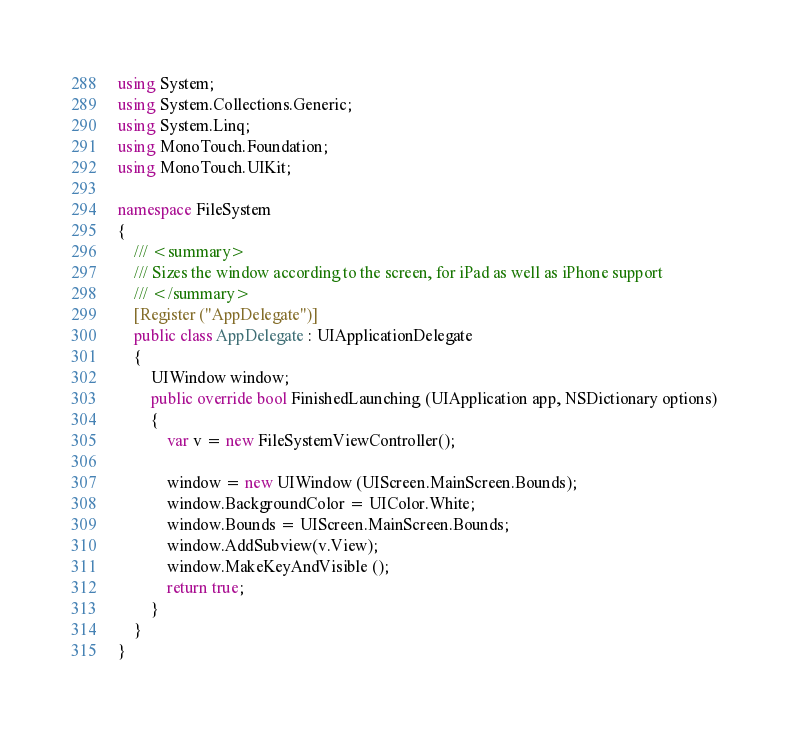<code> <loc_0><loc_0><loc_500><loc_500><_C#_>
using System;
using System.Collections.Generic;
using System.Linq;
using MonoTouch.Foundation;
using MonoTouch.UIKit;

namespace FileSystem
{
	/// <summary>
	/// Sizes the window according to the screen, for iPad as well as iPhone support
	/// </summary>
	[Register ("AppDelegate")]
	public class AppDelegate : UIApplicationDelegate
	{
		UIWindow window;
		public override bool FinishedLaunching (UIApplication app, NSDictionary options)
		{
			var v = new FileSystemViewController();
			
			window = new UIWindow (UIScreen.MainScreen.Bounds);	
			window.BackgroundColor = UIColor.White;
			window.Bounds = UIScreen.MainScreen.Bounds;
			window.AddSubview(v.View);
            window.MakeKeyAndVisible ();
			return true;
		}
	}
}</code> 